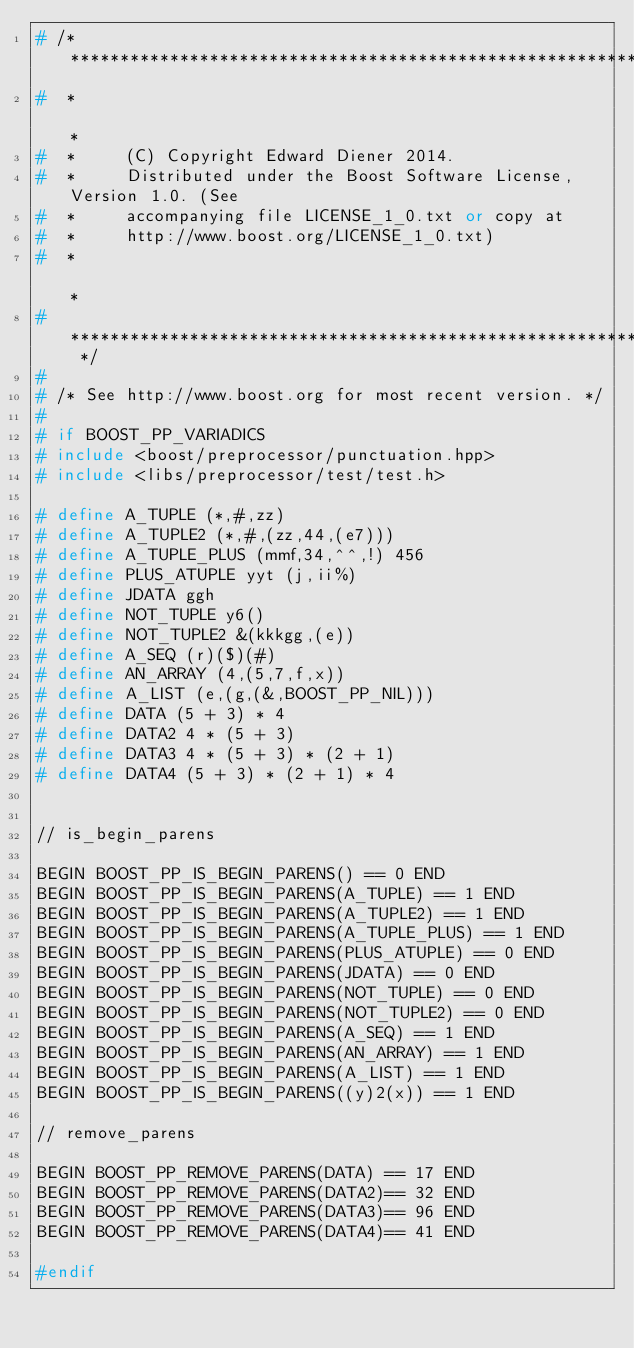Convert code to text. <code><loc_0><loc_0><loc_500><loc_500><_C++_># /* **************************************************************************
#  *                                                                          *
#  *     (C) Copyright Edward Diener 2014.
#  *     Distributed under the Boost Software License, Version 1.0. (See
#  *     accompanying file LICENSE_1_0.txt or copy at
#  *     http://www.boost.org/LICENSE_1_0.txt)
#  *                                                                          *
#  ************************************************************************** */
#
# /* See http://www.boost.org for most recent version. */
#
# if BOOST_PP_VARIADICS
# include <boost/preprocessor/punctuation.hpp>
# include <libs/preprocessor/test/test.h>

# define A_TUPLE (*,#,zz)
# define A_TUPLE2 (*,#,(zz,44,(e7)))
# define A_TUPLE_PLUS (mmf,34,^^,!) 456
# define PLUS_ATUPLE yyt (j,ii%)
# define JDATA ggh
# define NOT_TUPLE y6()
# define NOT_TUPLE2 &(kkkgg,(e))
# define A_SEQ (r)($)(#)
# define AN_ARRAY (4,(5,7,f,x))
# define A_LIST (e,(g,(&,BOOST_PP_NIL)))
# define DATA (5 + 3) * 4
# define DATA2 4 * (5 + 3)
# define DATA3 4 * (5 + 3) * (2 + 1)
# define DATA4 (5 + 3) * (2 + 1) * 4


// is_begin_parens

BEGIN BOOST_PP_IS_BEGIN_PARENS() == 0 END
BEGIN BOOST_PP_IS_BEGIN_PARENS(A_TUPLE) == 1 END
BEGIN BOOST_PP_IS_BEGIN_PARENS(A_TUPLE2) == 1 END
BEGIN BOOST_PP_IS_BEGIN_PARENS(A_TUPLE_PLUS) == 1 END
BEGIN BOOST_PP_IS_BEGIN_PARENS(PLUS_ATUPLE) == 0 END
BEGIN BOOST_PP_IS_BEGIN_PARENS(JDATA) == 0 END
BEGIN BOOST_PP_IS_BEGIN_PARENS(NOT_TUPLE) == 0 END
BEGIN BOOST_PP_IS_BEGIN_PARENS(NOT_TUPLE2) == 0 END
BEGIN BOOST_PP_IS_BEGIN_PARENS(A_SEQ) == 1 END
BEGIN BOOST_PP_IS_BEGIN_PARENS(AN_ARRAY) == 1 END
BEGIN BOOST_PP_IS_BEGIN_PARENS(A_LIST) == 1 END
BEGIN BOOST_PP_IS_BEGIN_PARENS((y)2(x)) == 1 END

// remove_parens

BEGIN BOOST_PP_REMOVE_PARENS(DATA) == 17 END
BEGIN BOOST_PP_REMOVE_PARENS(DATA2)== 32 END
BEGIN BOOST_PP_REMOVE_PARENS(DATA3)== 96 END
BEGIN BOOST_PP_REMOVE_PARENS(DATA4)== 41 END

#endif
</code> 